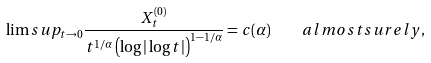<formula> <loc_0><loc_0><loc_500><loc_500>\lim s u p _ { t \to 0 } \frac { X ^ { ( 0 ) } _ { t } } { t ^ { 1 / \alpha } \left ( \log | \log t | \right ) ^ { 1 - 1 / \alpha } } = c ( \alpha ) \quad a l m o s t s u r e l y ,</formula> 